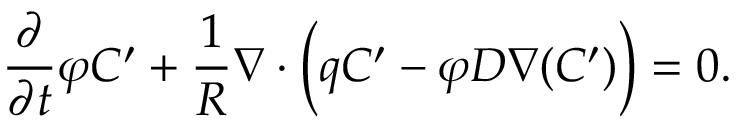<formula> <loc_0><loc_0><loc_500><loc_500>\frac { \partial } { \partial t } \varphi C ^ { \prime } + \frac { 1 } { R } { \nabla } \cdot \left ( { q } C ^ { \prime } - \varphi D { \nabla } ( C ^ { \prime } ) \right ) = 0 .</formula> 